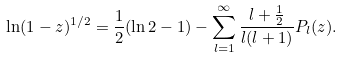<formula> <loc_0><loc_0><loc_500><loc_500>\ln ( 1 - z ) ^ { 1 / 2 } = { \frac { 1 } { 2 } } ( \ln 2 - 1 ) - \sum _ { l = 1 } ^ { \infty } \frac { l + \frac { 1 } { 2 } } { l ( l + 1 ) } P _ { l } ( z ) .</formula> 